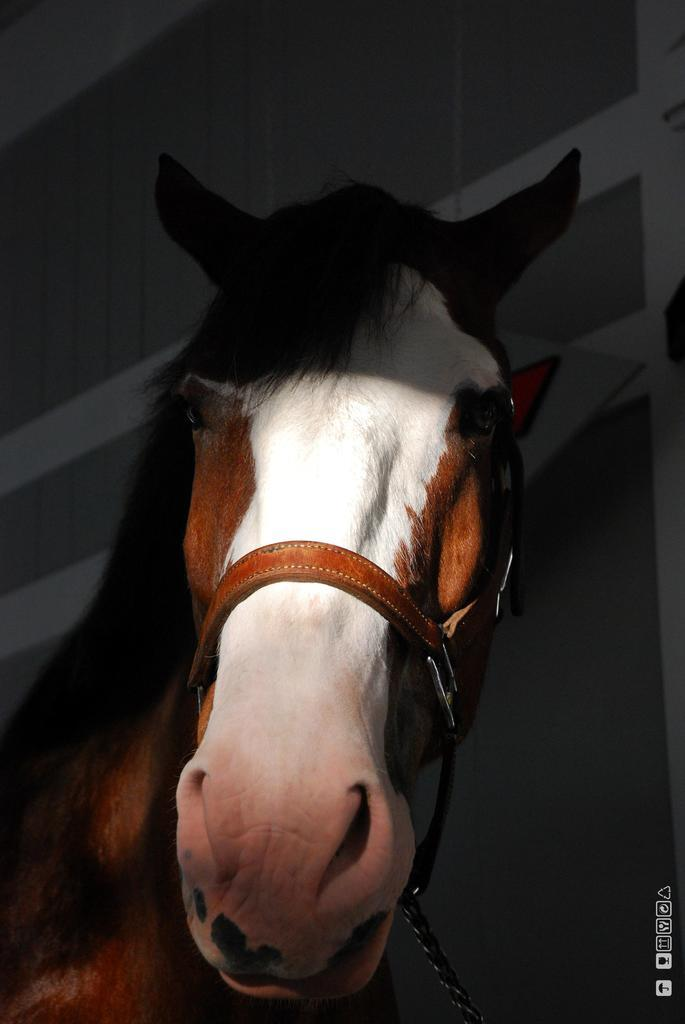What is the main subject in the foreground of the image? There is a horse in the foreground of the image. How much of the horse is visible in the image? The horse is truncated up to its neck in the image. Is there anything attached to the horse's neck? Yes, there is a rope tied to the horse's neck. What can be seen in the background of the image? There is a wall in the background of the image. Can you tell me how many babies are sitting on the queen's lap in the image? There are no babies or queens present in the image; it features a horse with a rope tied to its neck and a wall in the background. 